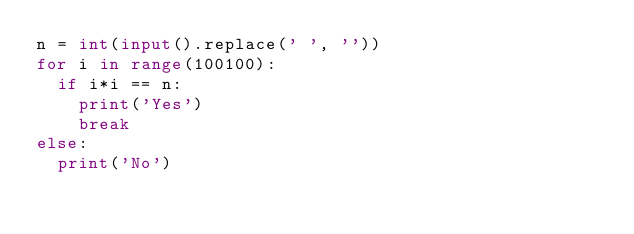Convert code to text. <code><loc_0><loc_0><loc_500><loc_500><_Python_>n = int(input().replace(' ', ''))
for i in range(100100):
  if i*i == n:
    print('Yes')
    break
else:
  print('No')</code> 